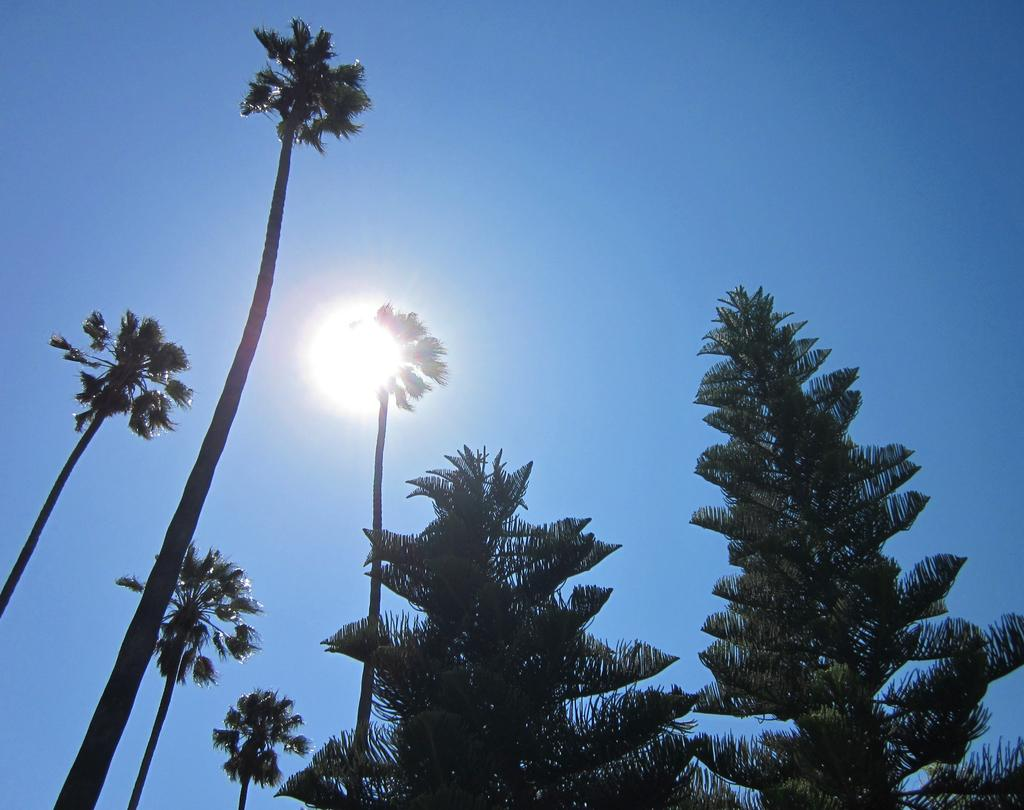What celestial body can be seen in the sky in the image? The sun is visible in the sky in the image. What type of vegetation is present in the middle of the image? There are trees in the middle of the image. Can you see a donkey playing with a spade in the image? No, there is no donkey or spade present in the image. 